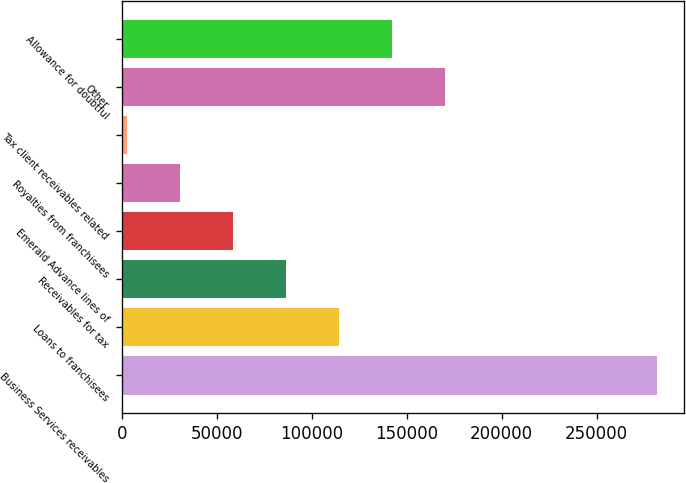Convert chart. <chart><loc_0><loc_0><loc_500><loc_500><bar_chart><fcel>Business Services receivables<fcel>Loans to franchisees<fcel>Receivables for tax<fcel>Emerald Advance lines of<fcel>Royalties from franchisees<fcel>Tax client receivables related<fcel>Other<fcel>Allowance for doubtful<nl><fcel>281847<fcel>114186<fcel>86242.5<fcel>58299<fcel>30355.5<fcel>2412<fcel>170073<fcel>142130<nl></chart> 